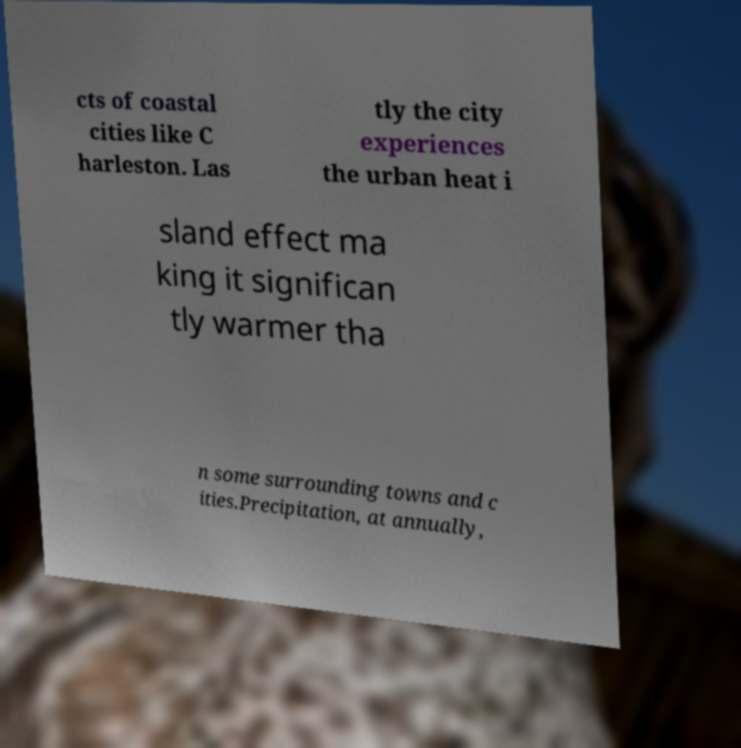For documentation purposes, I need the text within this image transcribed. Could you provide that? cts of coastal cities like C harleston. Las tly the city experiences the urban heat i sland effect ma king it significan tly warmer tha n some surrounding towns and c ities.Precipitation, at annually, 